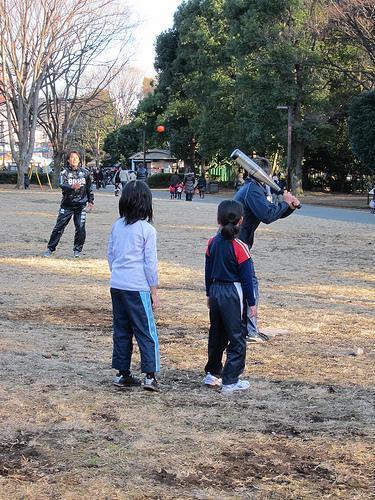How many people are holding a bat?
Give a very brief answer. 1. 